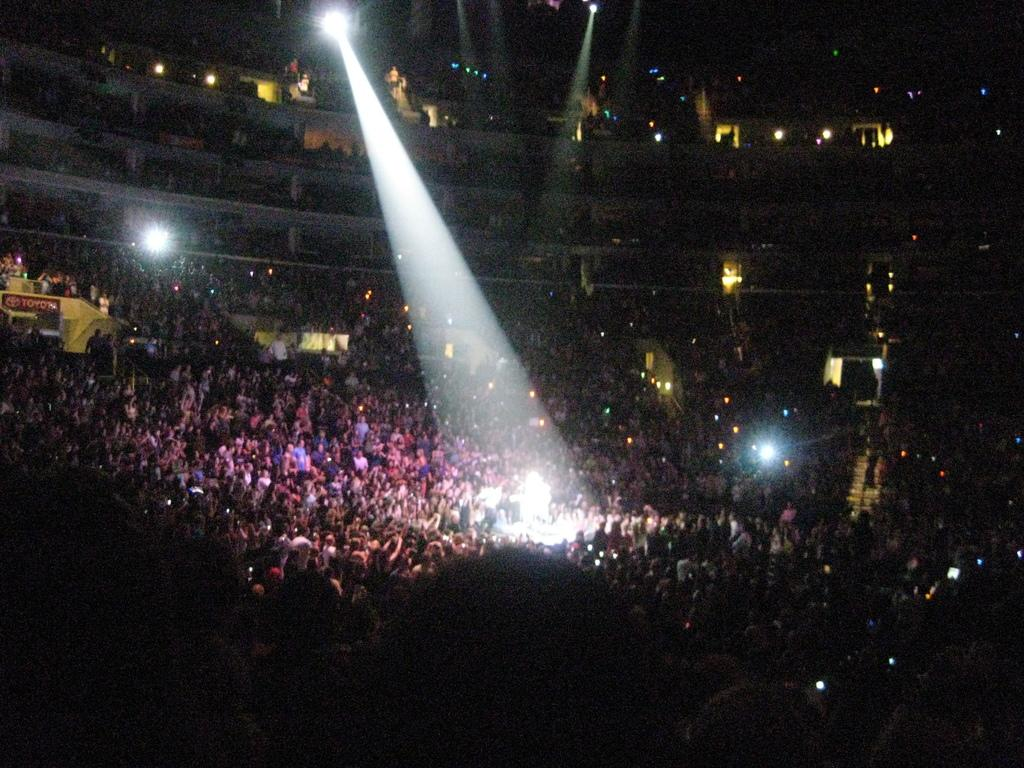What is the main subject of the image? The main subject of the image is groups of people. What type of event might be taking place in the image? The image appears to be from a show or performance. What can be seen illuminating the stage or performance area? There are stage lights visible in the image. Where was the image taken? The image was taken inside a building. What type of lighting is present in the image? There are lights present in the image. What type of coach is present in the image? There is no coach present in the image. How do the people in the image say good-bye to each other? The image does not show any interactions between the people, so it cannot be determined how they say good-bye to each other. 